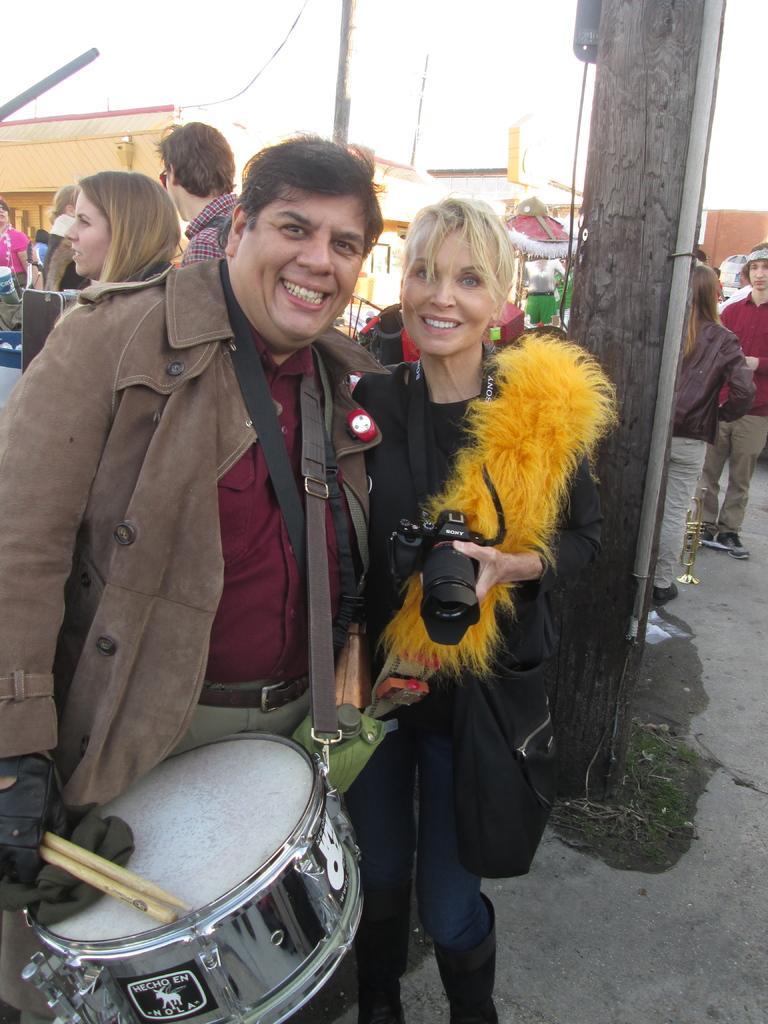Please provide a concise description of this image. In front of the image there are two people holding the camera, wooden sticks in their hands and they are having a smile on their faces. Behind them there are a few other people standing. There are wooden poles, buildings. At the top of the image there is sky.  